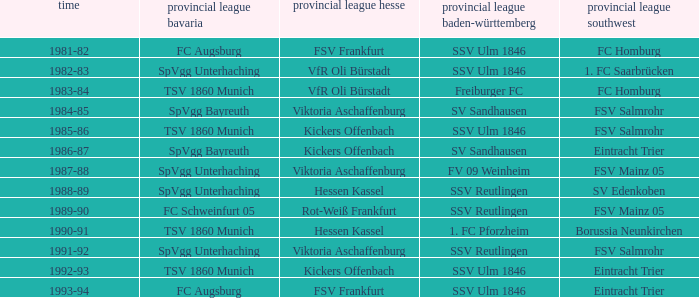Which oberliga baden-württemberg has a season of 1991-92? SSV Reutlingen. 